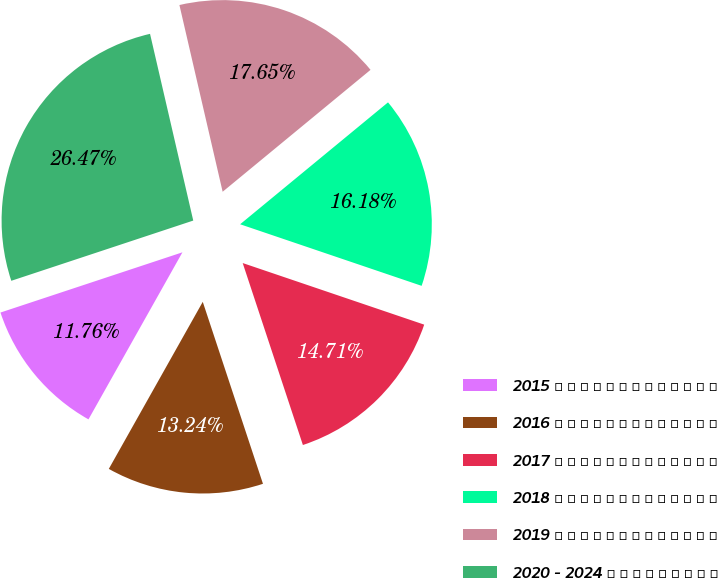Convert chart to OTSL. <chart><loc_0><loc_0><loc_500><loc_500><pie_chart><fcel>2015 � � � � � � � � � � � � �<fcel>2016 � � � � � � � � � � � � �<fcel>2017 � � � � � � � � � � � � �<fcel>2018 � � � � � � � � � � � � �<fcel>2019 � � � � � � � � � � � � �<fcel>2020 - 2024 � � � � � � � � �<nl><fcel>11.76%<fcel>13.24%<fcel>14.71%<fcel>16.18%<fcel>17.65%<fcel>26.47%<nl></chart> 